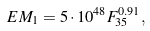Convert formula to latex. <formula><loc_0><loc_0><loc_500><loc_500>E M _ { 1 } = 5 \cdot 1 0 ^ { 4 8 } F _ { 3 5 } ^ { 0 . 9 1 } ,</formula> 